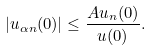Convert formula to latex. <formula><loc_0><loc_0><loc_500><loc_500>| u _ { \alpha n } ( 0 ) | \leq \frac { A u _ { n } ( 0 ) } { u ( 0 ) } .</formula> 